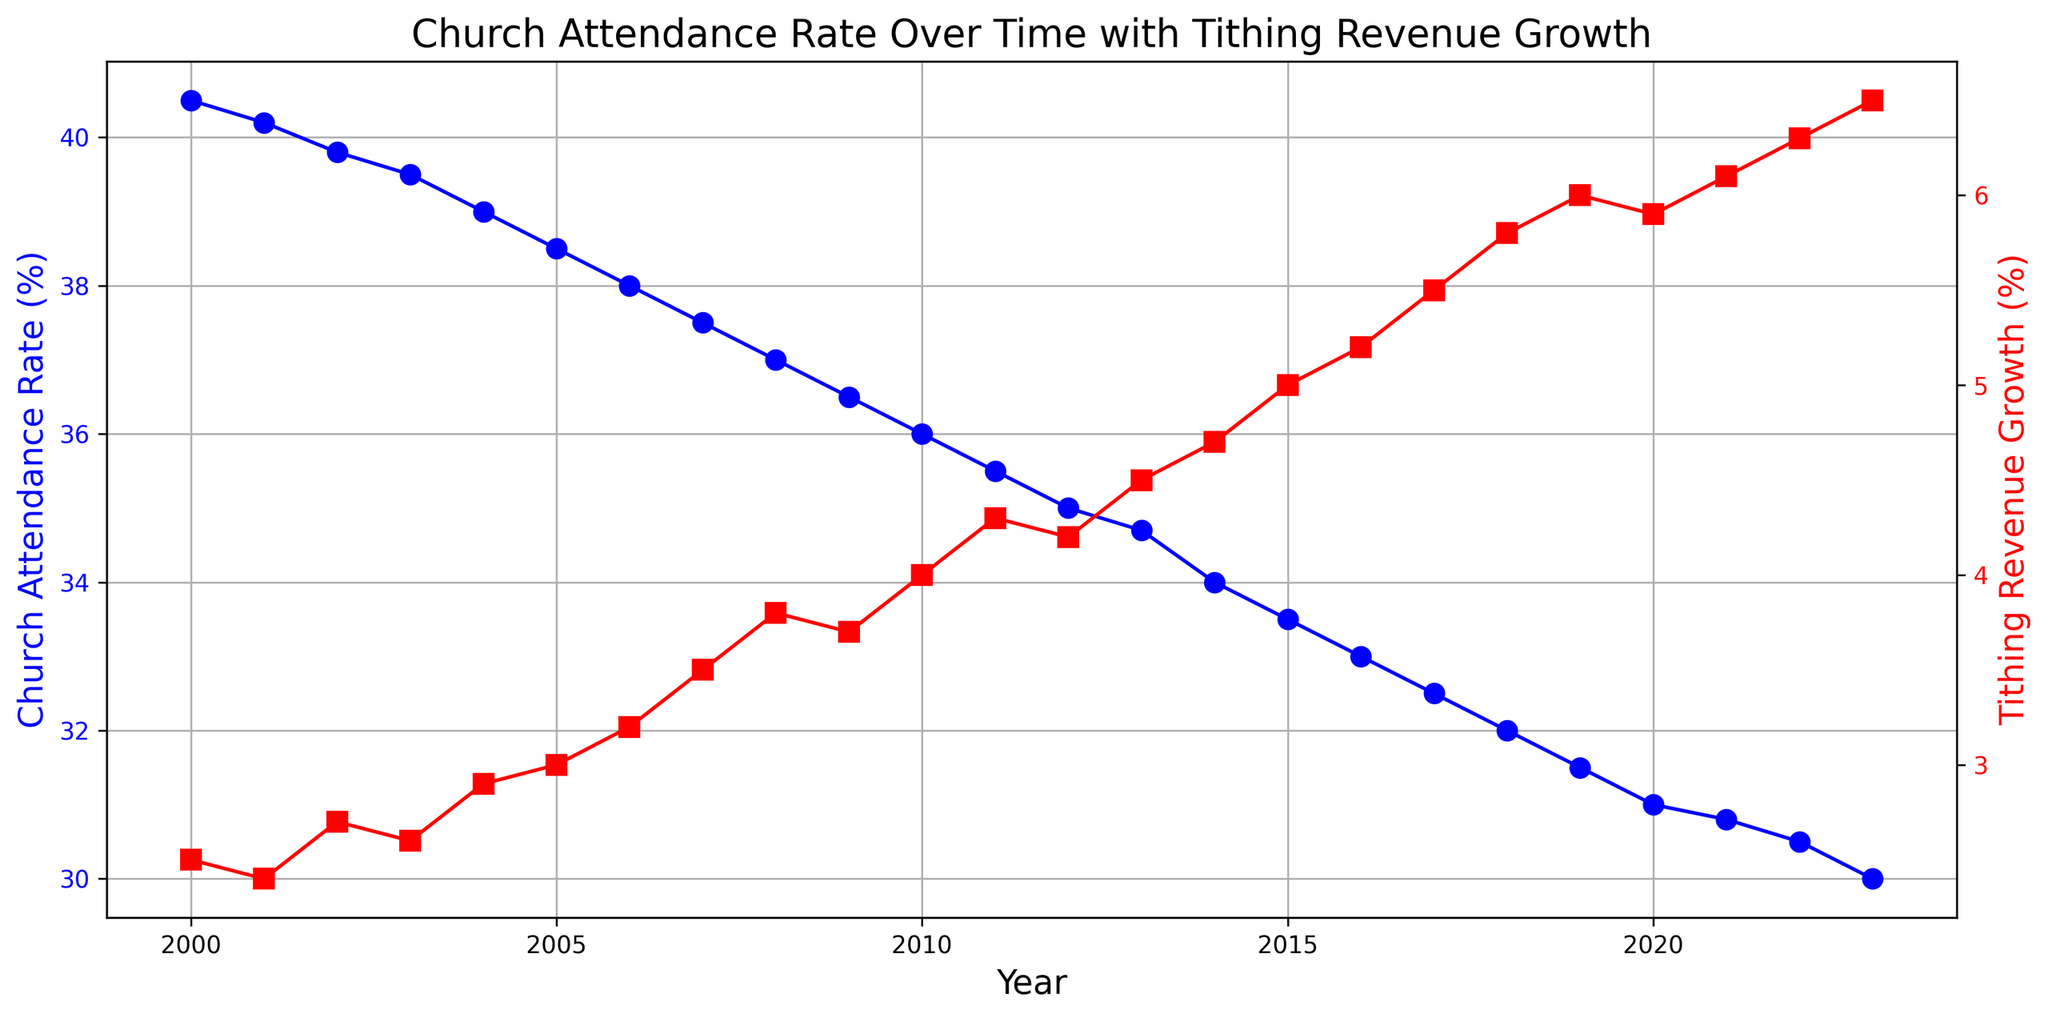What trend do you observe in the church attendance rate from 2000 to 2023? The church attendance rate shows a consistent declining trend from 40.5% in 2000 to 30.0% in 2023. This can be observed by looking at the blue line that steadily decreases over time on the chart.
Answer: It declines How does the trend in tithing revenue growth compare to the trend in church attendance rate from 2000 to 2023? While the church attendance rate is decreasing, the tithing revenue growth shows an increasing trend from 2.5% in 2000 to 6.5% in 2023. This can be observed by comparing the downward blue line (church attendance rate) and the upward red line (tithing revenue growth) over the same period.
Answer: They are opposite At what year do church attendance rate and tithing revenue growth begin to sharply diverge? The trends begin to noticeably diverge around 2007. From this year onwards, the church attendance rate continues to decrease, while tithing revenue growth begins to increase more steeply.
Answer: 2007 What is the difference in church attendance rate between 2000 and 2023? The church attendance rate in 2000 is 40.5% and it is 30.0% in 2023. The difference is 40.5% - 30.0% = 10.5%. Thus, there has been a decline of 10.5 percentage points.
Answer: 10.5% Compare the tithing revenue growth rate in 2005 and 2023. By how much has it increased? The tithing revenue growth rate in 2005 is 3.0% and in 2023 it is 6.5%. The increase is 6.5% - 3.0% = 3.5%.
Answer: 3.5% Which year had the highest growth percentage in tithing revenue and what was the value? By comparison of the red line representing tithing revenue growth, the highest growth percentage is in 2023 with a value of 6.5%.
Answer: 2023, 6.5% In which year did the church attendance rate fall below 35% for the first time? Church attendance rate falls below 35% for the first time in 2013 with a value of 34.7%. This can be observed by looking at the blue line where it dips below the 35% mark.
Answer: 2013 Calculate the average tithing revenue growth from 2010 to 2020. To find the average tithing revenue growth from 2010 to 2020: add the values from each year (4.0 + 4.3 + 4.2 + 4.5 + 4.7 + 5.0 + 5.2 + 5.5 + 5.8 + 6.0 + 5.9), then divide by the number of years (11). Sum is 55.1, average = 55.1 / 11 = 5.01%.
Answer: 5.01% Describe the visual relationship between the two lines (church attendance rate and tithing revenue growth) from 2015 to 2020. From 2015 to 2020, the blue line (church attendance rate) shows a continuing decline, while the red line (tithing revenue growth) shows a steady increase. This divergence visually represents the contrast between decreasing attendance and increasing revenue growth.
Answer: Divergence 